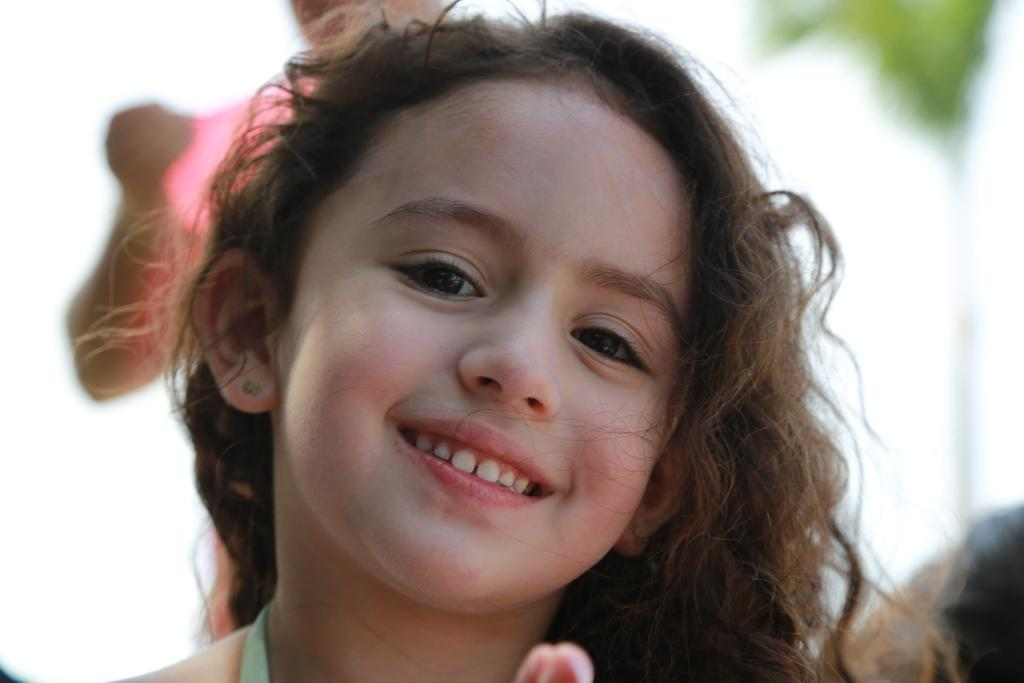Who is the main subject in the image? There is a girl in the image. Can you describe any other person in the image? There is a person in the background of the image. What type of wax is the girl using to bite in the image? There is no wax or biting activity present in the image. 